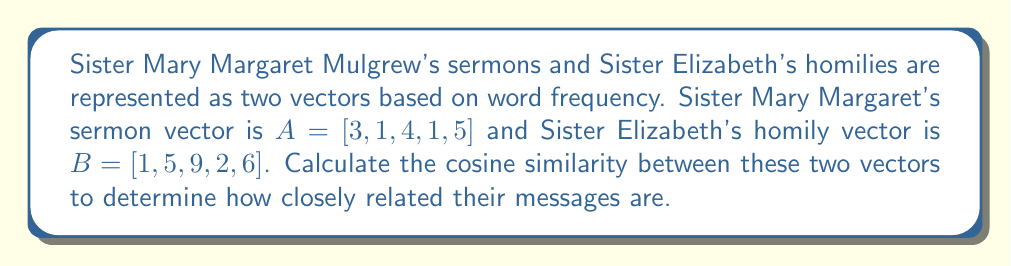Solve this math problem. To compute the cosine similarity between two vectors, we use the formula:

$$\text{cosine similarity} = \frac{A \cdot B}{\|A\| \|B\|}$$

Where $A \cdot B$ is the dot product of the vectors, and $\|A\|$ and $\|B\|$ are the magnitudes (Euclidean norms) of vectors A and B respectively.

Step 1: Calculate the dot product $A \cdot B$
$A \cdot B = (3 \times 1) + (1 \times 5) + (4 \times 9) + (1 \times 2) + (5 \times 6) = 3 + 5 + 36 + 2 + 30 = 76$

Step 2: Calculate $\|A\|$
$\|A\| = \sqrt{3^2 + 1^2 + 4^2 + 1^2 + 5^2} = \sqrt{9 + 1 + 16 + 1 + 25} = \sqrt{52} \approx 7.21110$

Step 3: Calculate $\|B\|$
$\|B\| = \sqrt{1^2 + 5^2 + 9^2 + 2^2 + 6^2} = \sqrt{1 + 25 + 81 + 4 + 36} = \sqrt{147} \approx 12.12436$

Step 4: Apply the cosine similarity formula
$$\text{cosine similarity} = \frac{76}{7.21110 \times 12.12436} \approx 0.87040$$
Answer: The cosine similarity between Sister Mary Margaret's sermon vector and Sister Elizabeth's homily vector is approximately 0.87040. 